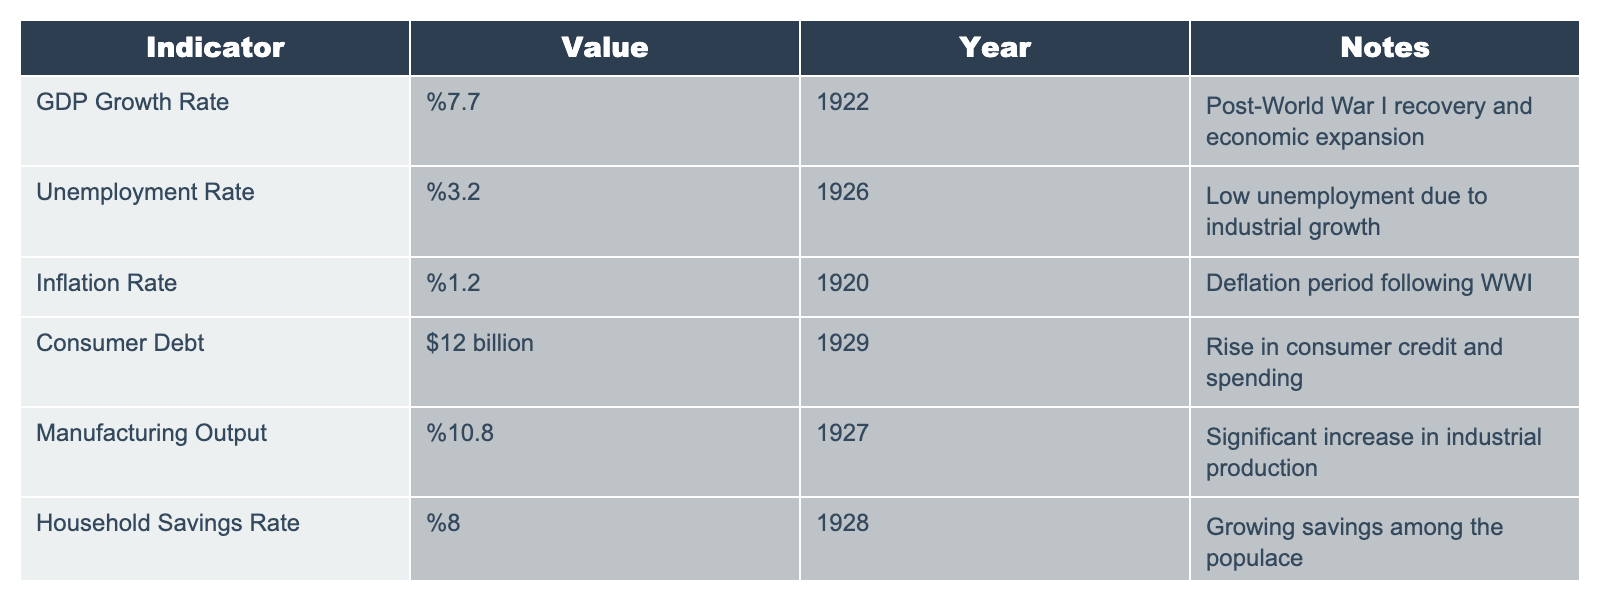What was the GDP growth rate in 1922? The table clearly states the GDP growth rate for the year 1922 is 7.7%.
Answer: 7.7% What was the unemployment rate in 1926? According to the table, the unemployment rate in 1926 is provided as 3.2%.
Answer: 3.2% What was the inflation rate for the year 1920? The table indicates that the inflation rate for 1920 is 1.2%.
Answer: 1.2% What was the consumer debt amount in 1929? The table mentions that consumer debt in 1929 reached $12 billion.
Answer: $12 billion What was the manufacturing output percentage in 1927? The table provides the manufacturing output percentage for 1927 as 10.8%.
Answer: 10.8% What is the average household savings rate from 1928? The table lists only one data point for household savings in 1928, which is 8%. Therefore, the average is the same as this value.
Answer: 8% Is the unemployment rate lower than 5% in 1926? Yes, the unemployment rate in 1926 is 3.2%, which is indeed lower than 5%.
Answer: Yes Which year had the highest GDP growth rate? From the data, the highest GDP growth rate is in 1922 at 7.7%.
Answer: 1922 What was the difference between the manufacturing output in 1927 and the inflation rate in 1920? The manufacturing output in 1927 is 10.8% and the inflation rate in 1920 is 1.2%. Calculating the difference: 10.8% - 1.2% = 9.6%.
Answer: 9.6% If we sum the unemployment rates for 1926 and the inflation rate for 1920, what do we get? For 1926, the unemployment rate is 3.2%, and the inflation rate for 1920 is 1.2%. Summing these: 3.2 + 1.2 = 4.4.
Answer: 4.4 Was consumer debt in 1929 more than the combined household savings in 1928? Consumer debt in 1929 is $12 billion and household savings in 1928 is calculated as a percentage of income rather than an absolute dollar value, thus we cannot directly compare this without specific context on average income levels for that period.
Answer: Not determinable without additional information 